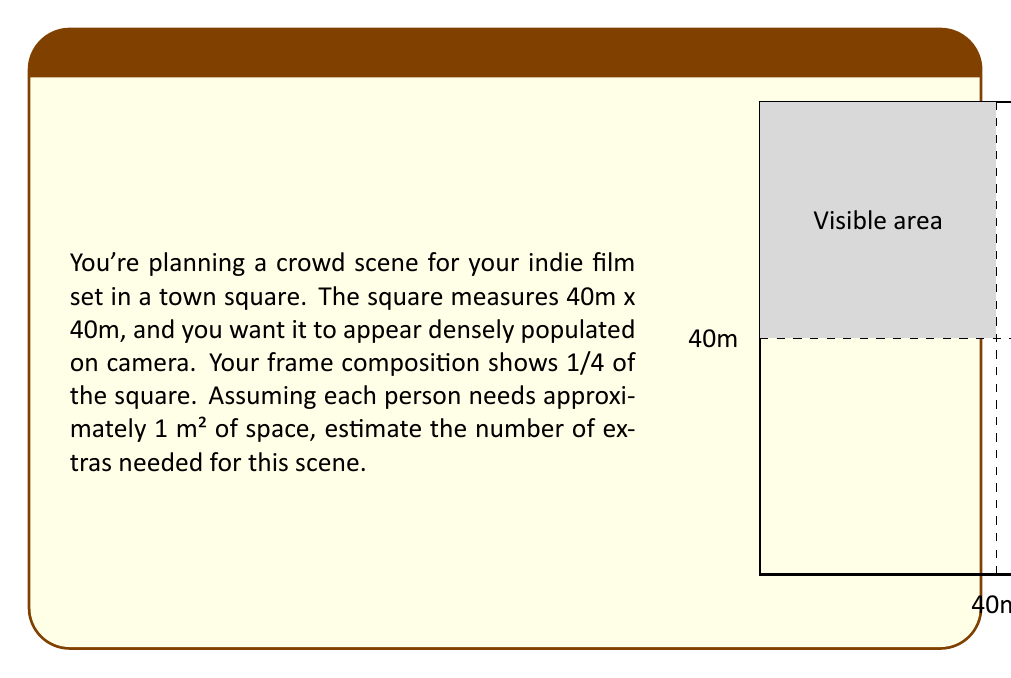Solve this math problem. Let's approach this step-by-step:

1) First, we need to calculate the total area of the square:
   $$A_{total} = 40\text{m} \times 40\text{m} = 1600\text{m}^2$$

2) The frame composition shows 1/4 of the square. To calculate this area:
   $$A_{visible} = \frac{1}{4} \times 1600\text{m}^2 = 400\text{m}^2$$

3) We're told that each person needs approximately 1 m² of space. This means the number of people that can fit in the visible area is equal to the area in square meters:
   $$N_{people} = A_{visible} = 400$$

4) However, for a densely populated appearance, we might want to add some extra people. A common practice is to increase by about 20%:
   $$N_{extras} = N_{people} \times 1.2 = 400 \times 1.2 = 480$$

5) Since we're estimating, it's reasonable to round this to the nearest 10:
   $$N_{extras} \approx 480$$
Answer: 480 extras 